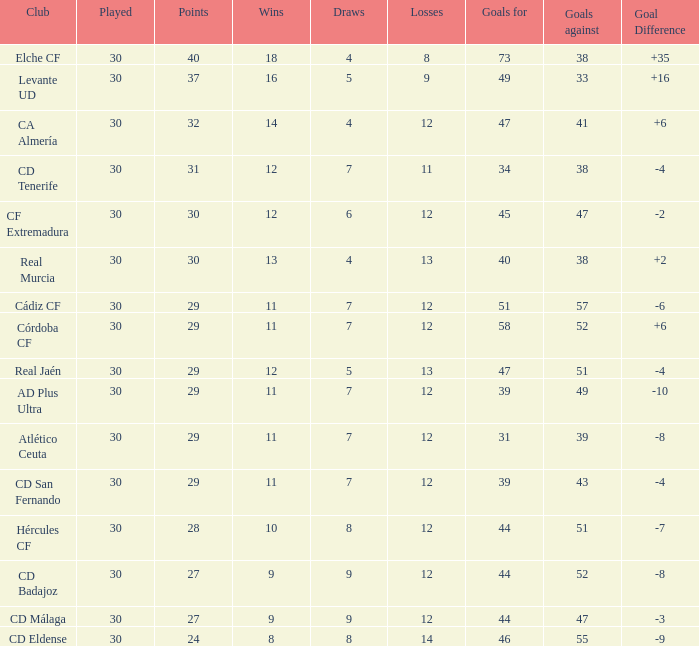What is the number of goals with less than 14 wins and a goal difference less than -4? 51, 39, 31, 44, 44, 46. 